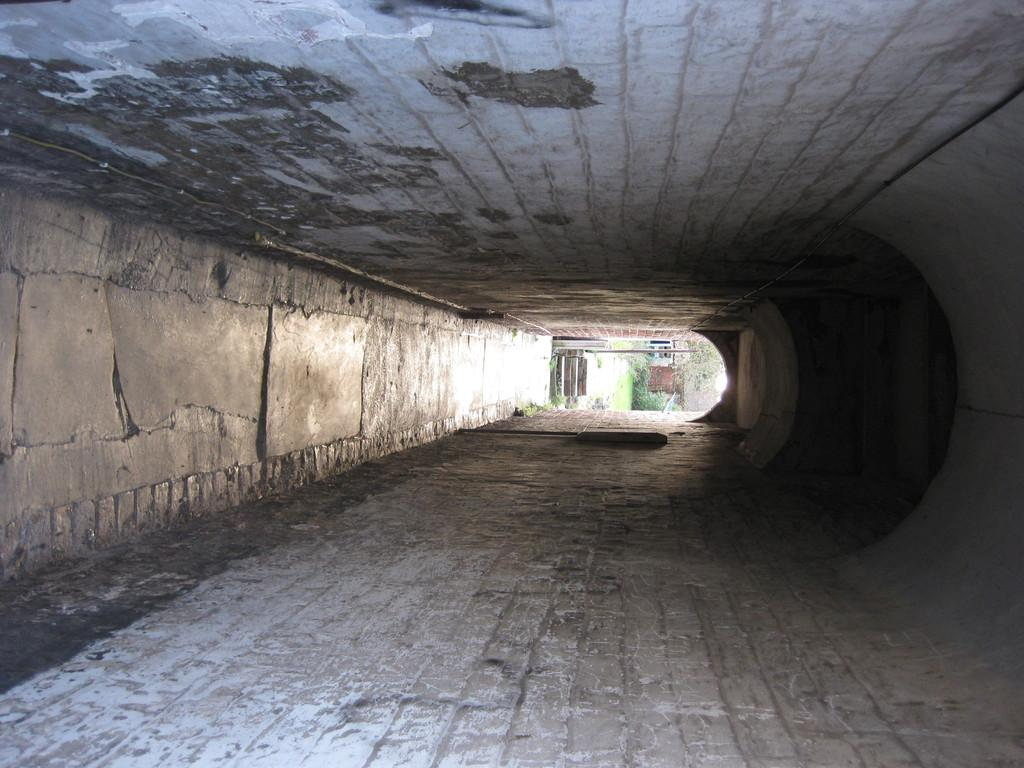What type of structure is visible in the image? There is a tunnel in the image. What can be seen near the tunnel? There is a walkway in the image. What covers the tunnel and walkway? There is a roof in the image. What can be seen in the distance in the image? Trees and soil are visible in the background of the image. Are there any other objects or features in the background of the image? Yes, there are additional objects in the background of the image. How many mice can be seen running on the walkway in the image? There are no mice present in the image; it only features a tunnel, walkway, roof, trees, soil, and additional objects in the background. What type of tank is visible in the image? There is no tank present in the image. 